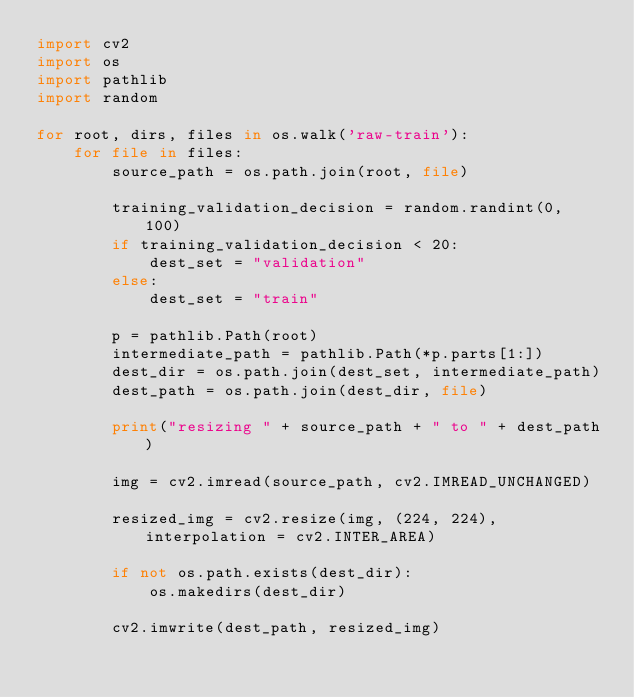<code> <loc_0><loc_0><loc_500><loc_500><_Python_>import cv2
import os
import pathlib
import random

for root, dirs, files in os.walk('raw-train'):
    for file in files:
        source_path = os.path.join(root, file)

        training_validation_decision = random.randint(0, 100)
        if training_validation_decision < 20:
            dest_set = "validation"
        else:
            dest_set = "train"

        p = pathlib.Path(root)
        intermediate_path = pathlib.Path(*p.parts[1:])
        dest_dir = os.path.join(dest_set, intermediate_path)
        dest_path = os.path.join(dest_dir, file)

        print("resizing " + source_path + " to " + dest_path)

        img = cv2.imread(source_path, cv2.IMREAD_UNCHANGED)

        resized_img = cv2.resize(img, (224, 224), interpolation = cv2.INTER_AREA)

        if not os.path.exists(dest_dir):
            os.makedirs(dest_dir)

        cv2.imwrite(dest_path, resized_img)

</code> 